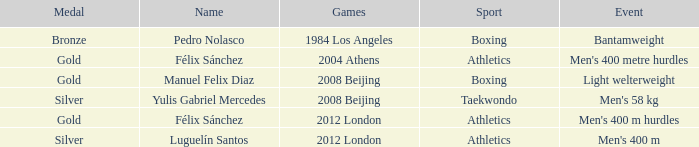Which Sport had an Event of men's 400 m hurdles? Athletics. 